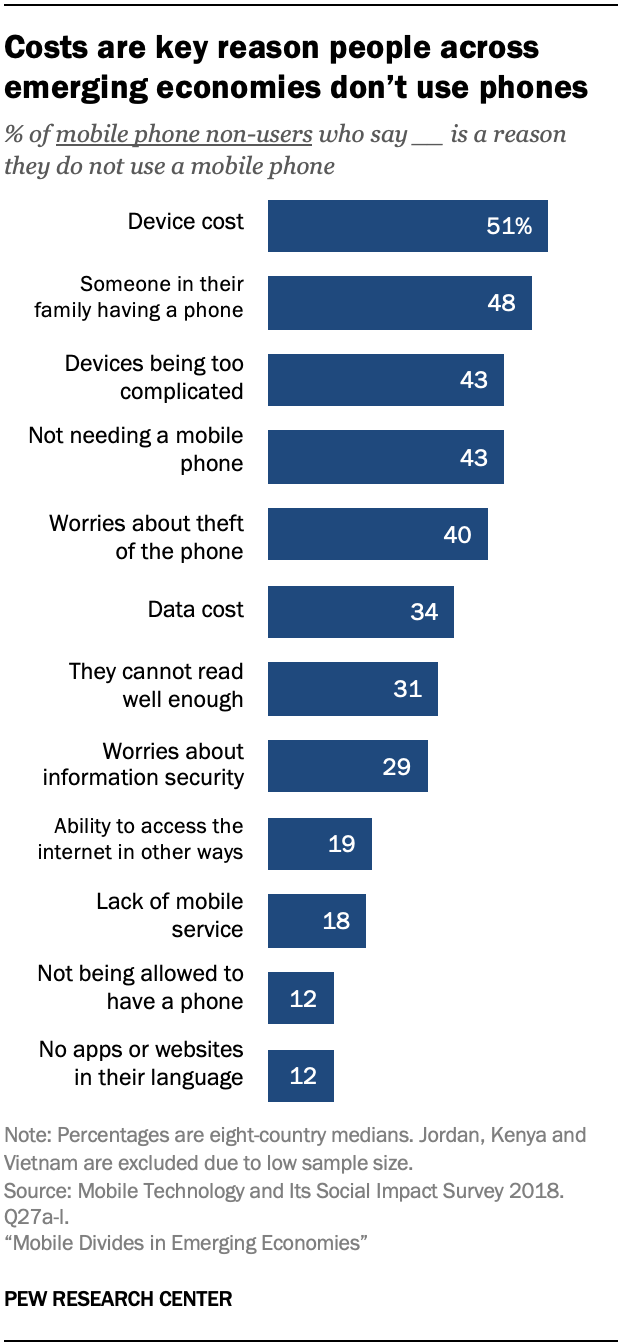Identify some key points in this picture. The value of the "Data cost" bar in the graph is 34. Is the sum of the two smallest values greater than the value of the "Lack of mobile service" bar in the graph? Yes. 